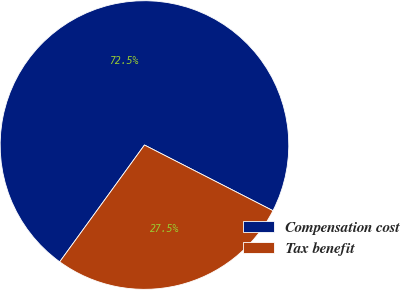Convert chart. <chart><loc_0><loc_0><loc_500><loc_500><pie_chart><fcel>Compensation cost<fcel>Tax benefit<nl><fcel>72.53%<fcel>27.47%<nl></chart> 